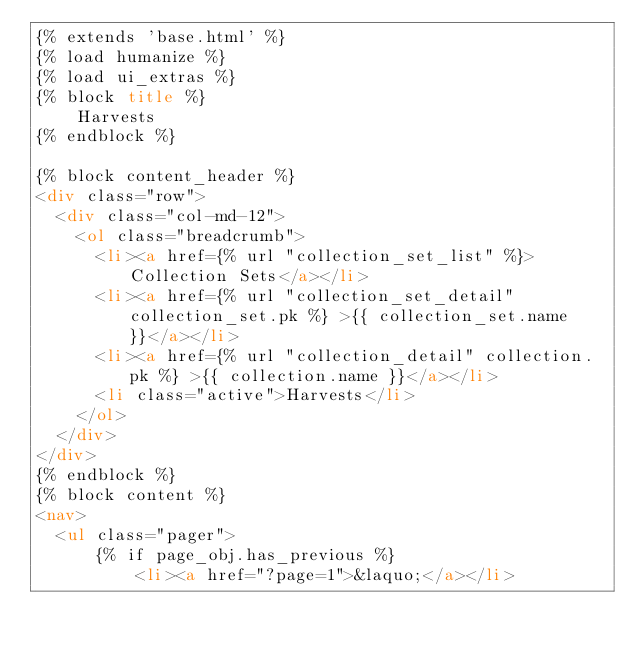<code> <loc_0><loc_0><loc_500><loc_500><_HTML_>{% extends 'base.html' %}
{% load humanize %}
{% load ui_extras %}
{% block title %}
    Harvests
{% endblock %}

{% block content_header %}
<div class="row">
  <div class="col-md-12">
    <ol class="breadcrumb">
      <li><a href={% url "collection_set_list" %}>Collection Sets</a></li>
      <li><a href={% url "collection_set_detail" collection_set.pk %} >{{ collection_set.name }}</a></li>
      <li><a href={% url "collection_detail" collection.pk %} >{{ collection.name }}</a></li>
      <li class="active">Harvests</li>
    </ol>
  </div>
</div>
{% endblock %}
{% block content %}
<nav>
  <ul class="pager">
      {% if page_obj.has_previous %}
          <li><a href="?page=1">&laquo;</a></li></code> 